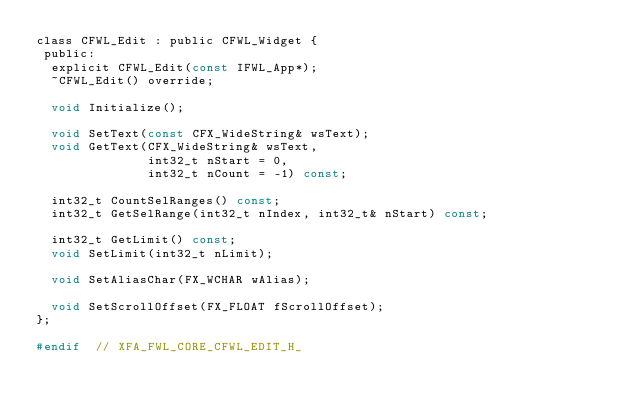Convert code to text. <code><loc_0><loc_0><loc_500><loc_500><_C_>class CFWL_Edit : public CFWL_Widget {
 public:
  explicit CFWL_Edit(const IFWL_App*);
  ~CFWL_Edit() override;

  void Initialize();

  void SetText(const CFX_WideString& wsText);
  void GetText(CFX_WideString& wsText,
               int32_t nStart = 0,
               int32_t nCount = -1) const;

  int32_t CountSelRanges() const;
  int32_t GetSelRange(int32_t nIndex, int32_t& nStart) const;

  int32_t GetLimit() const;
  void SetLimit(int32_t nLimit);

  void SetAliasChar(FX_WCHAR wAlias);

  void SetScrollOffset(FX_FLOAT fScrollOffset);
};

#endif  // XFA_FWL_CORE_CFWL_EDIT_H_
</code> 